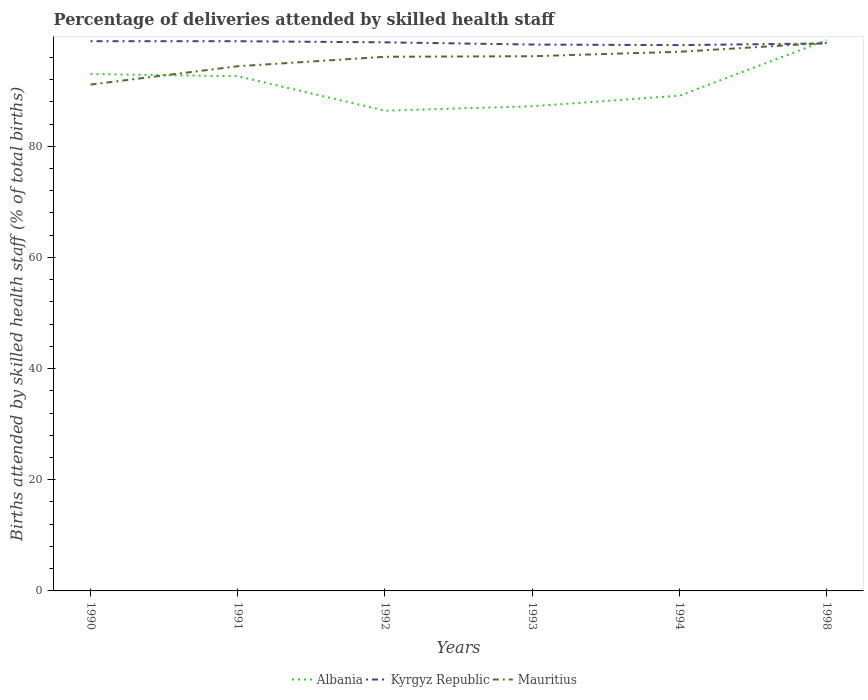How many different coloured lines are there?
Keep it short and to the point. 3. Does the line corresponding to Kyrgyz Republic intersect with the line corresponding to Albania?
Provide a succinct answer. Yes. Is the number of lines equal to the number of legend labels?
Ensure brevity in your answer.  Yes. Across all years, what is the maximum percentage of births attended by skilled health staff in Albania?
Give a very brief answer. 86.4. In which year was the percentage of births attended by skilled health staff in Mauritius maximum?
Keep it short and to the point. 1990. What is the total percentage of births attended by skilled health staff in Kyrgyz Republic in the graph?
Your response must be concise. 0.6. Is the percentage of births attended by skilled health staff in Mauritius strictly greater than the percentage of births attended by skilled health staff in Kyrgyz Republic over the years?
Ensure brevity in your answer.  No. How many lines are there?
Ensure brevity in your answer.  3. Does the graph contain any zero values?
Make the answer very short. No. Does the graph contain grids?
Your response must be concise. No. Where does the legend appear in the graph?
Provide a succinct answer. Bottom center. How many legend labels are there?
Give a very brief answer. 3. How are the legend labels stacked?
Provide a short and direct response. Horizontal. What is the title of the graph?
Your answer should be very brief. Percentage of deliveries attended by skilled health staff. What is the label or title of the Y-axis?
Give a very brief answer. Births attended by skilled health staff (% of total births). What is the Births attended by skilled health staff (% of total births) in Albania in 1990?
Offer a very short reply. 93. What is the Births attended by skilled health staff (% of total births) in Kyrgyz Republic in 1990?
Keep it short and to the point. 98.9. What is the Births attended by skilled health staff (% of total births) in Mauritius in 1990?
Your answer should be compact. 91.1. What is the Births attended by skilled health staff (% of total births) of Albania in 1991?
Provide a succinct answer. 92.6. What is the Births attended by skilled health staff (% of total births) in Kyrgyz Republic in 1991?
Keep it short and to the point. 98.9. What is the Births attended by skilled health staff (% of total births) in Mauritius in 1991?
Give a very brief answer. 94.4. What is the Births attended by skilled health staff (% of total births) in Albania in 1992?
Ensure brevity in your answer.  86.4. What is the Births attended by skilled health staff (% of total births) of Kyrgyz Republic in 1992?
Provide a short and direct response. 98.7. What is the Births attended by skilled health staff (% of total births) of Mauritius in 1992?
Offer a very short reply. 96.1. What is the Births attended by skilled health staff (% of total births) in Albania in 1993?
Your response must be concise. 87.2. What is the Births attended by skilled health staff (% of total births) in Kyrgyz Republic in 1993?
Provide a succinct answer. 98.3. What is the Births attended by skilled health staff (% of total births) in Mauritius in 1993?
Give a very brief answer. 96.2. What is the Births attended by skilled health staff (% of total births) in Albania in 1994?
Offer a very short reply. 89.1. What is the Births attended by skilled health staff (% of total births) in Kyrgyz Republic in 1994?
Ensure brevity in your answer.  98.2. What is the Births attended by skilled health staff (% of total births) in Mauritius in 1994?
Give a very brief answer. 97. What is the Births attended by skilled health staff (% of total births) in Albania in 1998?
Make the answer very short. 99.1. What is the Births attended by skilled health staff (% of total births) in Kyrgyz Republic in 1998?
Offer a very short reply. 98.5. What is the Births attended by skilled health staff (% of total births) in Mauritius in 1998?
Offer a terse response. 98.6. Across all years, what is the maximum Births attended by skilled health staff (% of total births) of Albania?
Your answer should be very brief. 99.1. Across all years, what is the maximum Births attended by skilled health staff (% of total births) in Kyrgyz Republic?
Offer a terse response. 98.9. Across all years, what is the maximum Births attended by skilled health staff (% of total births) in Mauritius?
Ensure brevity in your answer.  98.6. Across all years, what is the minimum Births attended by skilled health staff (% of total births) of Albania?
Ensure brevity in your answer.  86.4. Across all years, what is the minimum Births attended by skilled health staff (% of total births) in Kyrgyz Republic?
Provide a short and direct response. 98.2. Across all years, what is the minimum Births attended by skilled health staff (% of total births) of Mauritius?
Your response must be concise. 91.1. What is the total Births attended by skilled health staff (% of total births) in Albania in the graph?
Make the answer very short. 547.4. What is the total Births attended by skilled health staff (% of total births) of Kyrgyz Republic in the graph?
Provide a short and direct response. 591.5. What is the total Births attended by skilled health staff (% of total births) in Mauritius in the graph?
Offer a terse response. 573.4. What is the difference between the Births attended by skilled health staff (% of total births) of Albania in 1990 and that in 1991?
Offer a terse response. 0.4. What is the difference between the Births attended by skilled health staff (% of total births) in Kyrgyz Republic in 1990 and that in 1991?
Your answer should be compact. 0. What is the difference between the Births attended by skilled health staff (% of total births) in Mauritius in 1990 and that in 1991?
Your answer should be very brief. -3.3. What is the difference between the Births attended by skilled health staff (% of total births) of Albania in 1990 and that in 1992?
Offer a terse response. 6.6. What is the difference between the Births attended by skilled health staff (% of total births) of Mauritius in 1990 and that in 1992?
Your answer should be compact. -5. What is the difference between the Births attended by skilled health staff (% of total births) of Albania in 1990 and that in 1993?
Offer a very short reply. 5.8. What is the difference between the Births attended by skilled health staff (% of total births) of Mauritius in 1990 and that in 1993?
Ensure brevity in your answer.  -5.1. What is the difference between the Births attended by skilled health staff (% of total births) of Albania in 1990 and that in 1994?
Your answer should be very brief. 3.9. What is the difference between the Births attended by skilled health staff (% of total births) of Kyrgyz Republic in 1990 and that in 1994?
Your response must be concise. 0.7. What is the difference between the Births attended by skilled health staff (% of total births) of Albania in 1990 and that in 1998?
Your answer should be very brief. -6.1. What is the difference between the Births attended by skilled health staff (% of total births) of Kyrgyz Republic in 1990 and that in 1998?
Provide a short and direct response. 0.4. What is the difference between the Births attended by skilled health staff (% of total births) in Mauritius in 1990 and that in 1998?
Your response must be concise. -7.5. What is the difference between the Births attended by skilled health staff (% of total births) of Albania in 1991 and that in 1992?
Give a very brief answer. 6.2. What is the difference between the Births attended by skilled health staff (% of total births) of Kyrgyz Republic in 1991 and that in 1992?
Ensure brevity in your answer.  0.2. What is the difference between the Births attended by skilled health staff (% of total births) in Albania in 1991 and that in 1993?
Keep it short and to the point. 5.4. What is the difference between the Births attended by skilled health staff (% of total births) of Kyrgyz Republic in 1991 and that in 1993?
Your answer should be compact. 0.6. What is the difference between the Births attended by skilled health staff (% of total births) of Kyrgyz Republic in 1991 and that in 1994?
Keep it short and to the point. 0.7. What is the difference between the Births attended by skilled health staff (% of total births) in Mauritius in 1991 and that in 1994?
Provide a succinct answer. -2.6. What is the difference between the Births attended by skilled health staff (% of total births) of Albania in 1991 and that in 1998?
Provide a short and direct response. -6.5. What is the difference between the Births attended by skilled health staff (% of total births) in Kyrgyz Republic in 1991 and that in 1998?
Offer a terse response. 0.4. What is the difference between the Births attended by skilled health staff (% of total births) of Mauritius in 1991 and that in 1998?
Ensure brevity in your answer.  -4.2. What is the difference between the Births attended by skilled health staff (% of total births) in Kyrgyz Republic in 1992 and that in 1993?
Provide a succinct answer. 0.4. What is the difference between the Births attended by skilled health staff (% of total births) in Albania in 1992 and that in 1994?
Your answer should be compact. -2.7. What is the difference between the Births attended by skilled health staff (% of total births) in Kyrgyz Republic in 1992 and that in 1994?
Give a very brief answer. 0.5. What is the difference between the Births attended by skilled health staff (% of total births) of Mauritius in 1992 and that in 1994?
Offer a terse response. -0.9. What is the difference between the Births attended by skilled health staff (% of total births) in Albania in 1993 and that in 1994?
Keep it short and to the point. -1.9. What is the difference between the Births attended by skilled health staff (% of total births) of Mauritius in 1993 and that in 1994?
Your answer should be compact. -0.8. What is the difference between the Births attended by skilled health staff (% of total births) of Kyrgyz Republic in 1993 and that in 1998?
Ensure brevity in your answer.  -0.2. What is the difference between the Births attended by skilled health staff (% of total births) in Mauritius in 1993 and that in 1998?
Offer a very short reply. -2.4. What is the difference between the Births attended by skilled health staff (% of total births) of Albania in 1994 and that in 1998?
Keep it short and to the point. -10. What is the difference between the Births attended by skilled health staff (% of total births) in Albania in 1990 and the Births attended by skilled health staff (% of total births) in Kyrgyz Republic in 1991?
Your answer should be compact. -5.9. What is the difference between the Births attended by skilled health staff (% of total births) in Albania in 1990 and the Births attended by skilled health staff (% of total births) in Mauritius in 1992?
Ensure brevity in your answer.  -3.1. What is the difference between the Births attended by skilled health staff (% of total births) of Albania in 1990 and the Births attended by skilled health staff (% of total births) of Mauritius in 1993?
Your answer should be very brief. -3.2. What is the difference between the Births attended by skilled health staff (% of total births) of Albania in 1990 and the Births attended by skilled health staff (% of total births) of Kyrgyz Republic in 1994?
Your answer should be compact. -5.2. What is the difference between the Births attended by skilled health staff (% of total births) in Albania in 1990 and the Births attended by skilled health staff (% of total births) in Mauritius in 1994?
Give a very brief answer. -4. What is the difference between the Births attended by skilled health staff (% of total births) in Albania in 1990 and the Births attended by skilled health staff (% of total births) in Kyrgyz Republic in 1998?
Ensure brevity in your answer.  -5.5. What is the difference between the Births attended by skilled health staff (% of total births) in Albania in 1990 and the Births attended by skilled health staff (% of total births) in Mauritius in 1998?
Offer a terse response. -5.6. What is the difference between the Births attended by skilled health staff (% of total births) of Kyrgyz Republic in 1990 and the Births attended by skilled health staff (% of total births) of Mauritius in 1998?
Offer a very short reply. 0.3. What is the difference between the Births attended by skilled health staff (% of total births) of Kyrgyz Republic in 1991 and the Births attended by skilled health staff (% of total births) of Mauritius in 1992?
Your answer should be compact. 2.8. What is the difference between the Births attended by skilled health staff (% of total births) of Albania in 1991 and the Births attended by skilled health staff (% of total births) of Kyrgyz Republic in 1993?
Your answer should be very brief. -5.7. What is the difference between the Births attended by skilled health staff (% of total births) in Albania in 1991 and the Births attended by skilled health staff (% of total births) in Mauritius in 1993?
Your response must be concise. -3.6. What is the difference between the Births attended by skilled health staff (% of total births) in Kyrgyz Republic in 1991 and the Births attended by skilled health staff (% of total births) in Mauritius in 1993?
Offer a terse response. 2.7. What is the difference between the Births attended by skilled health staff (% of total births) of Albania in 1991 and the Births attended by skilled health staff (% of total births) of Kyrgyz Republic in 1994?
Your answer should be very brief. -5.6. What is the difference between the Births attended by skilled health staff (% of total births) of Albania in 1991 and the Births attended by skilled health staff (% of total births) of Mauritius in 1994?
Keep it short and to the point. -4.4. What is the difference between the Births attended by skilled health staff (% of total births) in Albania in 1991 and the Births attended by skilled health staff (% of total births) in Mauritius in 1998?
Your answer should be very brief. -6. What is the difference between the Births attended by skilled health staff (% of total births) of Kyrgyz Republic in 1992 and the Births attended by skilled health staff (% of total births) of Mauritius in 1993?
Keep it short and to the point. 2.5. What is the difference between the Births attended by skilled health staff (% of total births) in Albania in 1992 and the Births attended by skilled health staff (% of total births) in Kyrgyz Republic in 1994?
Make the answer very short. -11.8. What is the difference between the Births attended by skilled health staff (% of total births) of Albania in 1992 and the Births attended by skilled health staff (% of total births) of Mauritius in 1994?
Make the answer very short. -10.6. What is the difference between the Births attended by skilled health staff (% of total births) in Albania in 1992 and the Births attended by skilled health staff (% of total births) in Kyrgyz Republic in 1998?
Your answer should be compact. -12.1. What is the difference between the Births attended by skilled health staff (% of total births) in Kyrgyz Republic in 1992 and the Births attended by skilled health staff (% of total births) in Mauritius in 1998?
Your response must be concise. 0.1. What is the difference between the Births attended by skilled health staff (% of total births) of Albania in 1993 and the Births attended by skilled health staff (% of total births) of Kyrgyz Republic in 1994?
Keep it short and to the point. -11. What is the difference between the Births attended by skilled health staff (% of total births) in Albania in 1993 and the Births attended by skilled health staff (% of total births) in Mauritius in 1994?
Your answer should be very brief. -9.8. What is the difference between the Births attended by skilled health staff (% of total births) of Kyrgyz Republic in 1993 and the Births attended by skilled health staff (% of total births) of Mauritius in 1994?
Provide a succinct answer. 1.3. What is the difference between the Births attended by skilled health staff (% of total births) in Albania in 1993 and the Births attended by skilled health staff (% of total births) in Kyrgyz Republic in 1998?
Your answer should be very brief. -11.3. What is the difference between the Births attended by skilled health staff (% of total births) of Kyrgyz Republic in 1994 and the Births attended by skilled health staff (% of total births) of Mauritius in 1998?
Give a very brief answer. -0.4. What is the average Births attended by skilled health staff (% of total births) in Albania per year?
Your response must be concise. 91.23. What is the average Births attended by skilled health staff (% of total births) of Kyrgyz Republic per year?
Offer a terse response. 98.58. What is the average Births attended by skilled health staff (% of total births) of Mauritius per year?
Give a very brief answer. 95.57. In the year 1990, what is the difference between the Births attended by skilled health staff (% of total births) in Albania and Births attended by skilled health staff (% of total births) in Kyrgyz Republic?
Your response must be concise. -5.9. In the year 1990, what is the difference between the Births attended by skilled health staff (% of total births) of Albania and Births attended by skilled health staff (% of total births) of Mauritius?
Your answer should be very brief. 1.9. In the year 1990, what is the difference between the Births attended by skilled health staff (% of total births) in Kyrgyz Republic and Births attended by skilled health staff (% of total births) in Mauritius?
Your response must be concise. 7.8. In the year 1992, what is the difference between the Births attended by skilled health staff (% of total births) of Albania and Births attended by skilled health staff (% of total births) of Kyrgyz Republic?
Make the answer very short. -12.3. In the year 1992, what is the difference between the Births attended by skilled health staff (% of total births) of Kyrgyz Republic and Births attended by skilled health staff (% of total births) of Mauritius?
Provide a succinct answer. 2.6. In the year 1994, what is the difference between the Births attended by skilled health staff (% of total births) of Albania and Births attended by skilled health staff (% of total births) of Kyrgyz Republic?
Your answer should be compact. -9.1. In the year 1994, what is the difference between the Births attended by skilled health staff (% of total births) of Kyrgyz Republic and Births attended by skilled health staff (% of total births) of Mauritius?
Offer a very short reply. 1.2. In the year 1998, what is the difference between the Births attended by skilled health staff (% of total births) of Kyrgyz Republic and Births attended by skilled health staff (% of total births) of Mauritius?
Provide a short and direct response. -0.1. What is the ratio of the Births attended by skilled health staff (% of total births) of Albania in 1990 to that in 1991?
Keep it short and to the point. 1. What is the ratio of the Births attended by skilled health staff (% of total births) in Kyrgyz Republic in 1990 to that in 1991?
Your answer should be very brief. 1. What is the ratio of the Births attended by skilled health staff (% of total births) in Albania in 1990 to that in 1992?
Make the answer very short. 1.08. What is the ratio of the Births attended by skilled health staff (% of total births) of Kyrgyz Republic in 1990 to that in 1992?
Provide a succinct answer. 1. What is the ratio of the Births attended by skilled health staff (% of total births) in Mauritius in 1990 to that in 1992?
Your response must be concise. 0.95. What is the ratio of the Births attended by skilled health staff (% of total births) of Albania in 1990 to that in 1993?
Offer a very short reply. 1.07. What is the ratio of the Births attended by skilled health staff (% of total births) in Kyrgyz Republic in 1990 to that in 1993?
Offer a terse response. 1.01. What is the ratio of the Births attended by skilled health staff (% of total births) in Mauritius in 1990 to that in 1993?
Ensure brevity in your answer.  0.95. What is the ratio of the Births attended by skilled health staff (% of total births) of Albania in 1990 to that in 1994?
Ensure brevity in your answer.  1.04. What is the ratio of the Births attended by skilled health staff (% of total births) of Kyrgyz Republic in 1990 to that in 1994?
Your answer should be very brief. 1.01. What is the ratio of the Births attended by skilled health staff (% of total births) of Mauritius in 1990 to that in 1994?
Give a very brief answer. 0.94. What is the ratio of the Births attended by skilled health staff (% of total births) of Albania in 1990 to that in 1998?
Offer a terse response. 0.94. What is the ratio of the Births attended by skilled health staff (% of total births) of Kyrgyz Republic in 1990 to that in 1998?
Make the answer very short. 1. What is the ratio of the Births attended by skilled health staff (% of total births) of Mauritius in 1990 to that in 1998?
Ensure brevity in your answer.  0.92. What is the ratio of the Births attended by skilled health staff (% of total births) in Albania in 1991 to that in 1992?
Provide a succinct answer. 1.07. What is the ratio of the Births attended by skilled health staff (% of total births) in Kyrgyz Republic in 1991 to that in 1992?
Give a very brief answer. 1. What is the ratio of the Births attended by skilled health staff (% of total births) in Mauritius in 1991 to that in 1992?
Offer a terse response. 0.98. What is the ratio of the Births attended by skilled health staff (% of total births) in Albania in 1991 to that in 1993?
Offer a very short reply. 1.06. What is the ratio of the Births attended by skilled health staff (% of total births) of Mauritius in 1991 to that in 1993?
Give a very brief answer. 0.98. What is the ratio of the Births attended by skilled health staff (% of total births) of Albania in 1991 to that in 1994?
Ensure brevity in your answer.  1.04. What is the ratio of the Births attended by skilled health staff (% of total births) in Kyrgyz Republic in 1991 to that in 1994?
Provide a short and direct response. 1.01. What is the ratio of the Births attended by skilled health staff (% of total births) of Mauritius in 1991 to that in 1994?
Your answer should be compact. 0.97. What is the ratio of the Births attended by skilled health staff (% of total births) in Albania in 1991 to that in 1998?
Your answer should be very brief. 0.93. What is the ratio of the Births attended by skilled health staff (% of total births) in Kyrgyz Republic in 1991 to that in 1998?
Your response must be concise. 1. What is the ratio of the Births attended by skilled health staff (% of total births) in Mauritius in 1991 to that in 1998?
Offer a terse response. 0.96. What is the ratio of the Births attended by skilled health staff (% of total births) in Kyrgyz Republic in 1992 to that in 1993?
Offer a terse response. 1. What is the ratio of the Births attended by skilled health staff (% of total births) in Albania in 1992 to that in 1994?
Ensure brevity in your answer.  0.97. What is the ratio of the Births attended by skilled health staff (% of total births) of Kyrgyz Republic in 1992 to that in 1994?
Your response must be concise. 1.01. What is the ratio of the Births attended by skilled health staff (% of total births) of Mauritius in 1992 to that in 1994?
Ensure brevity in your answer.  0.99. What is the ratio of the Births attended by skilled health staff (% of total births) of Albania in 1992 to that in 1998?
Your response must be concise. 0.87. What is the ratio of the Births attended by skilled health staff (% of total births) in Mauritius in 1992 to that in 1998?
Your answer should be compact. 0.97. What is the ratio of the Births attended by skilled health staff (% of total births) of Albania in 1993 to that in 1994?
Make the answer very short. 0.98. What is the ratio of the Births attended by skilled health staff (% of total births) of Albania in 1993 to that in 1998?
Provide a succinct answer. 0.88. What is the ratio of the Births attended by skilled health staff (% of total births) of Kyrgyz Republic in 1993 to that in 1998?
Provide a short and direct response. 1. What is the ratio of the Births attended by skilled health staff (% of total births) of Mauritius in 1993 to that in 1998?
Your response must be concise. 0.98. What is the ratio of the Births attended by skilled health staff (% of total births) in Albania in 1994 to that in 1998?
Your answer should be very brief. 0.9. What is the ratio of the Births attended by skilled health staff (% of total births) of Mauritius in 1994 to that in 1998?
Your answer should be very brief. 0.98. What is the difference between the highest and the lowest Births attended by skilled health staff (% of total births) of Mauritius?
Your response must be concise. 7.5. 